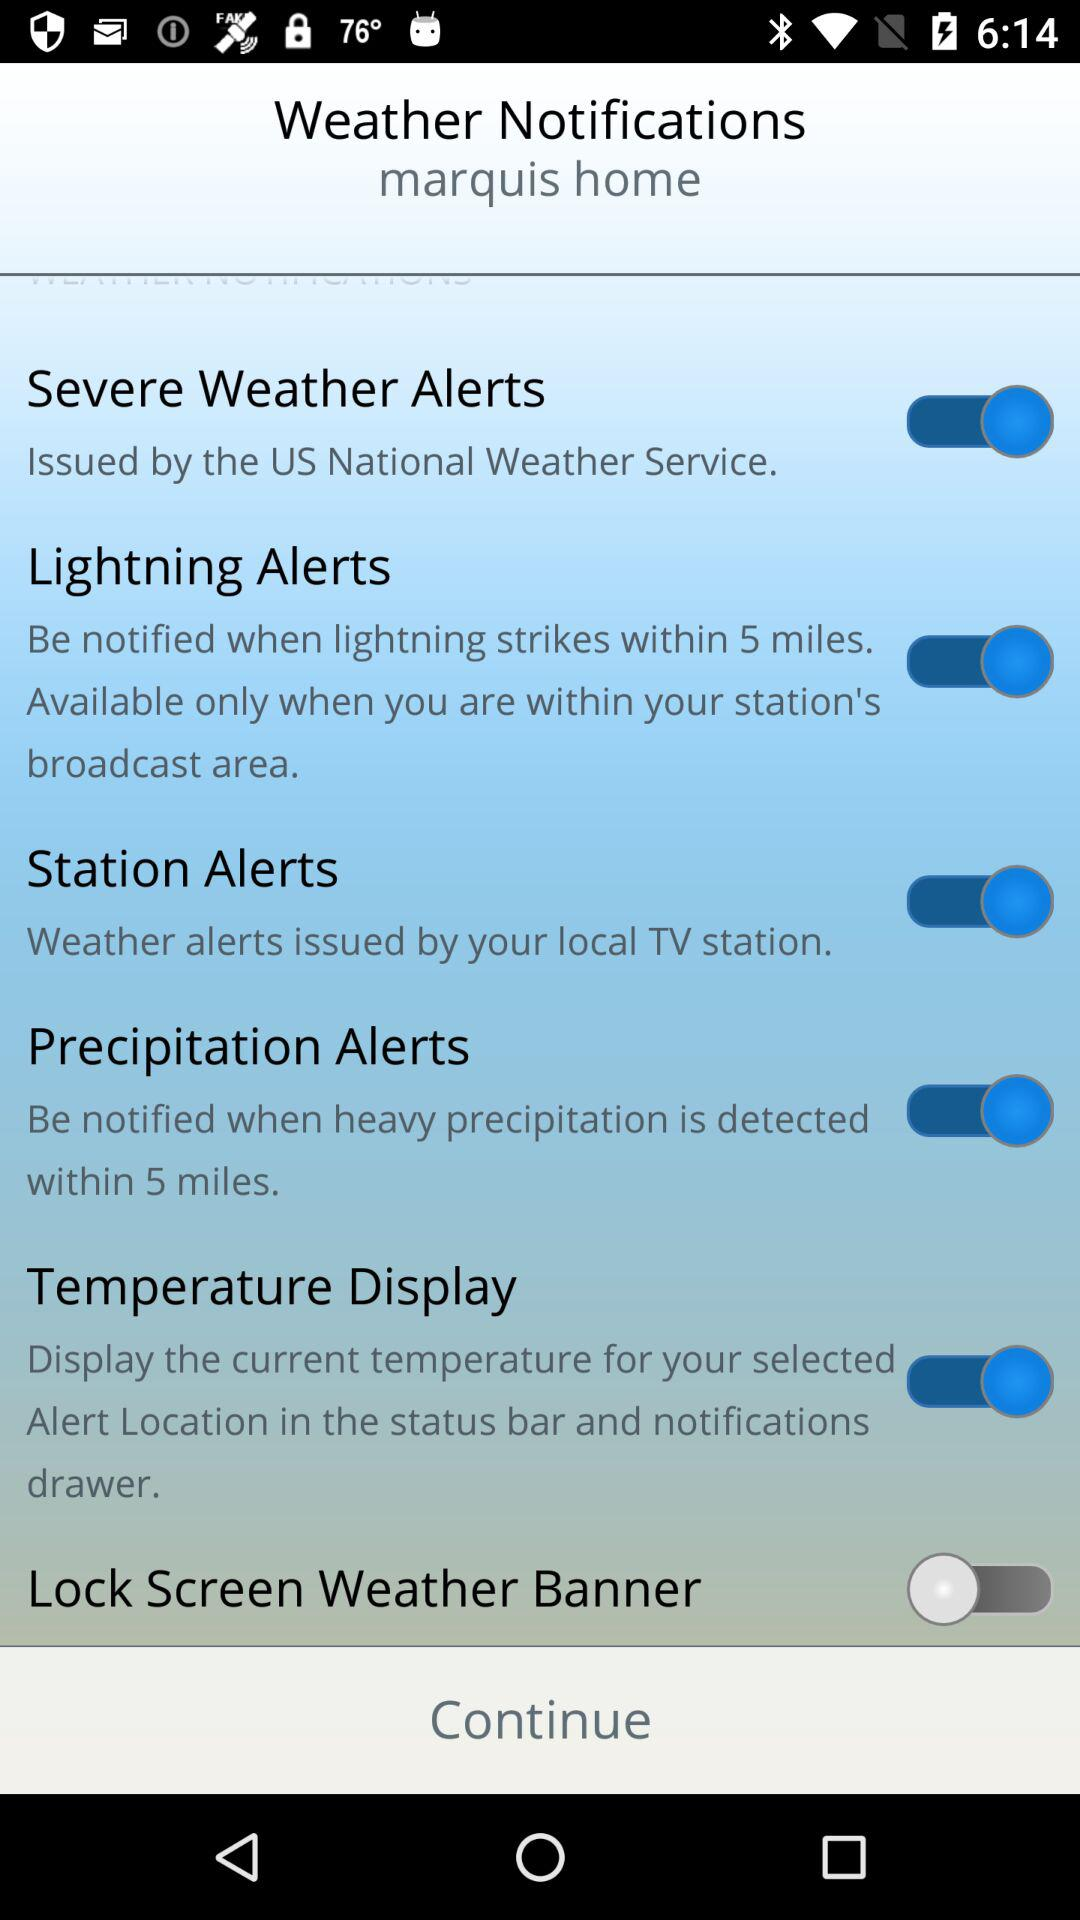When was the last severe weather alert issued?
When the provided information is insufficient, respond with <no answer>. <no answer> 